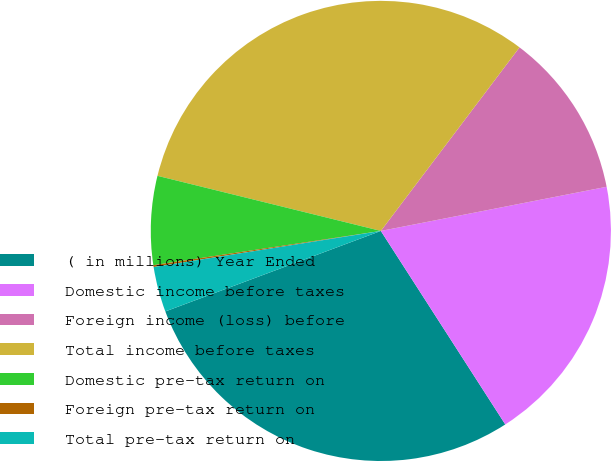Convert chart. <chart><loc_0><loc_0><loc_500><loc_500><pie_chart><fcel>( in millions) Year Ended<fcel>Domestic income before taxes<fcel>Foreign income (loss) before<fcel>Total income before taxes<fcel>Domestic pre-tax return on<fcel>Foreign pre-tax return on<fcel>Total pre-tax return on<nl><fcel>28.41%<fcel>18.98%<fcel>11.63%<fcel>31.45%<fcel>6.23%<fcel>0.13%<fcel>3.18%<nl></chart> 